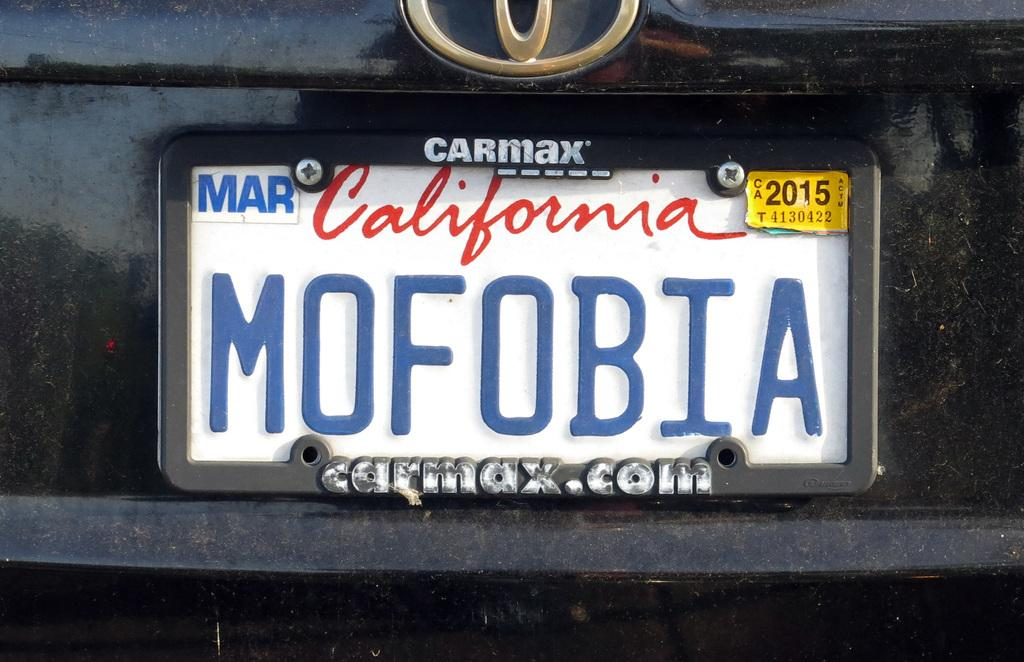Provide a one-sentence caption for the provided image. A California license plate with a carmax holder. 